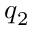Convert formula to latex. <formula><loc_0><loc_0><loc_500><loc_500>q _ { 2 }</formula> 